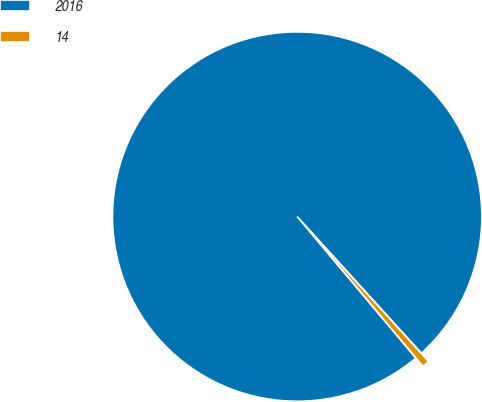<chart> <loc_0><loc_0><loc_500><loc_500><pie_chart><fcel>2016<fcel>14<nl><fcel>99.36%<fcel>0.64%<nl></chart> 